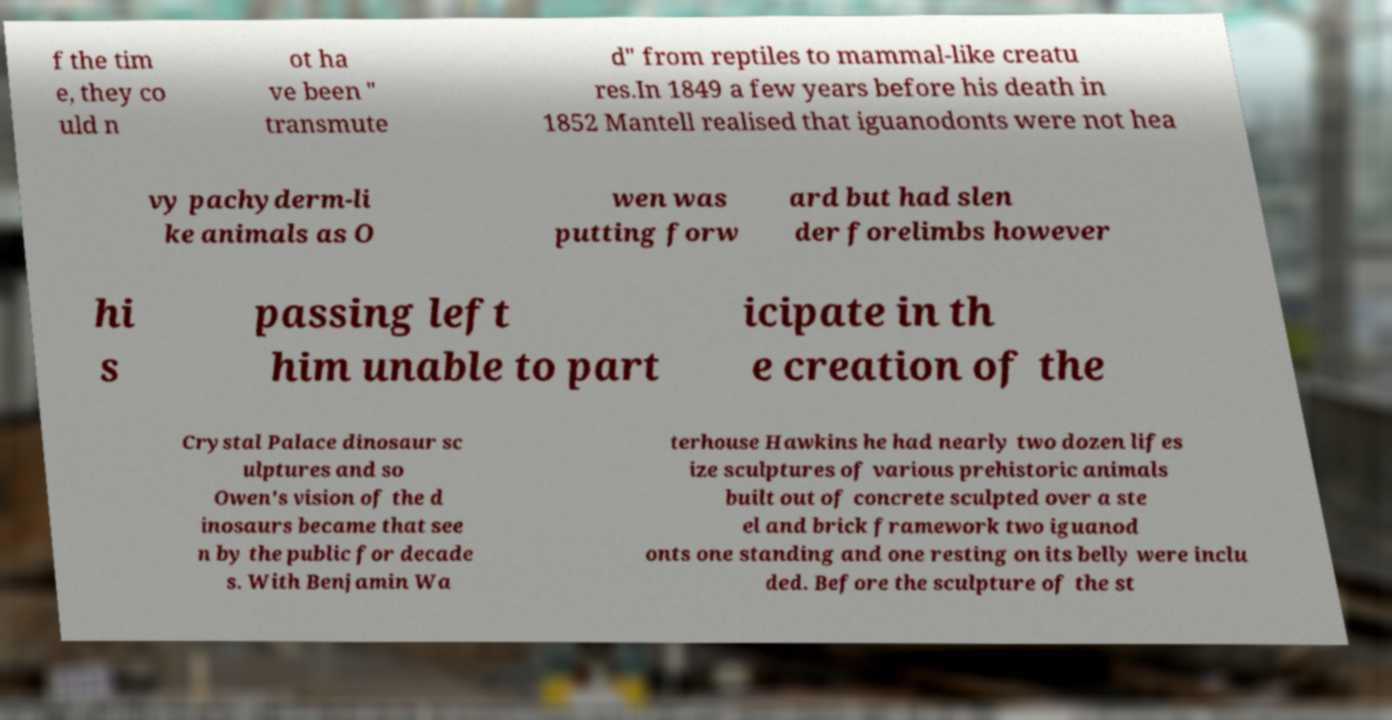Please identify and transcribe the text found in this image. f the tim e, they co uld n ot ha ve been " transmute d" from reptiles to mammal-like creatu res.In 1849 a few years before his death in 1852 Mantell realised that iguanodonts were not hea vy pachyderm-li ke animals as O wen was putting forw ard but had slen der forelimbs however hi s passing left him unable to part icipate in th e creation of the Crystal Palace dinosaur sc ulptures and so Owen's vision of the d inosaurs became that see n by the public for decade s. With Benjamin Wa terhouse Hawkins he had nearly two dozen lifes ize sculptures of various prehistoric animals built out of concrete sculpted over a ste el and brick framework two iguanod onts one standing and one resting on its belly were inclu ded. Before the sculpture of the st 